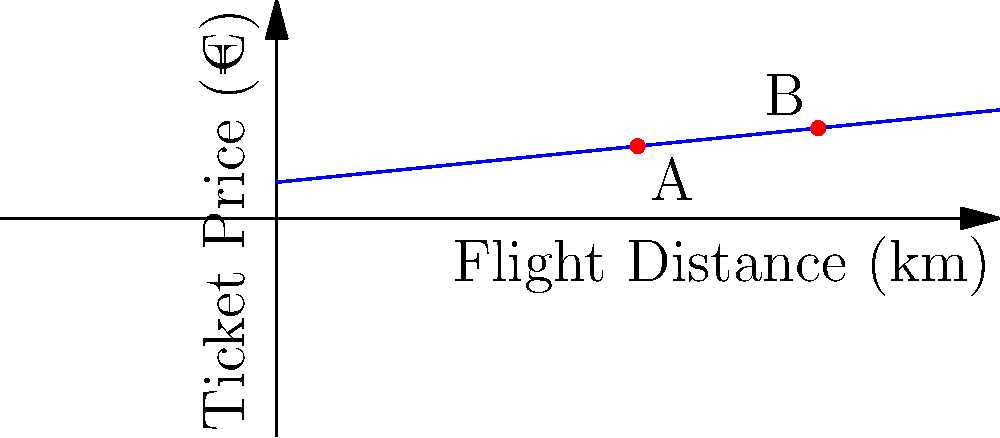In a deregulated aviation market, the relationship between ticket prices and flight distances can be modeled using a linear function. The graph shows this relationship, with ticket prices in euros on the y-axis and flight distances in kilometers on the x-axis. Points A and B represent two different flights. Given that the base fare is €50 and the price increases by €0.10 per kilometer, calculate the difference in ticket prices between flights A and B. To solve this problem, we'll follow these steps:

1. Identify the linear function:
   The ticket price (y) is a function of flight distance (x):
   $$y = 50 + 0.1x$$
   Where 50 is the base fare and 0.1 is the price increase per kilometer.

2. Determine the coordinates of points A and B:
   A: (500, 100)
   B: (750, 125)

3. Calculate the ticket price for flight A:
   $$y_A = 50 + 0.1(500) = 50 + 50 = 100$$

4. Calculate the ticket price for flight B:
   $$y_B = 50 + 0.1(750) = 50 + 75 = 125$$

5. Calculate the difference in ticket prices:
   $$\text{Difference} = y_B - y_A = 125 - 100 = 25$$

Therefore, the difference in ticket prices between flights A and B is €25.
Answer: €25 